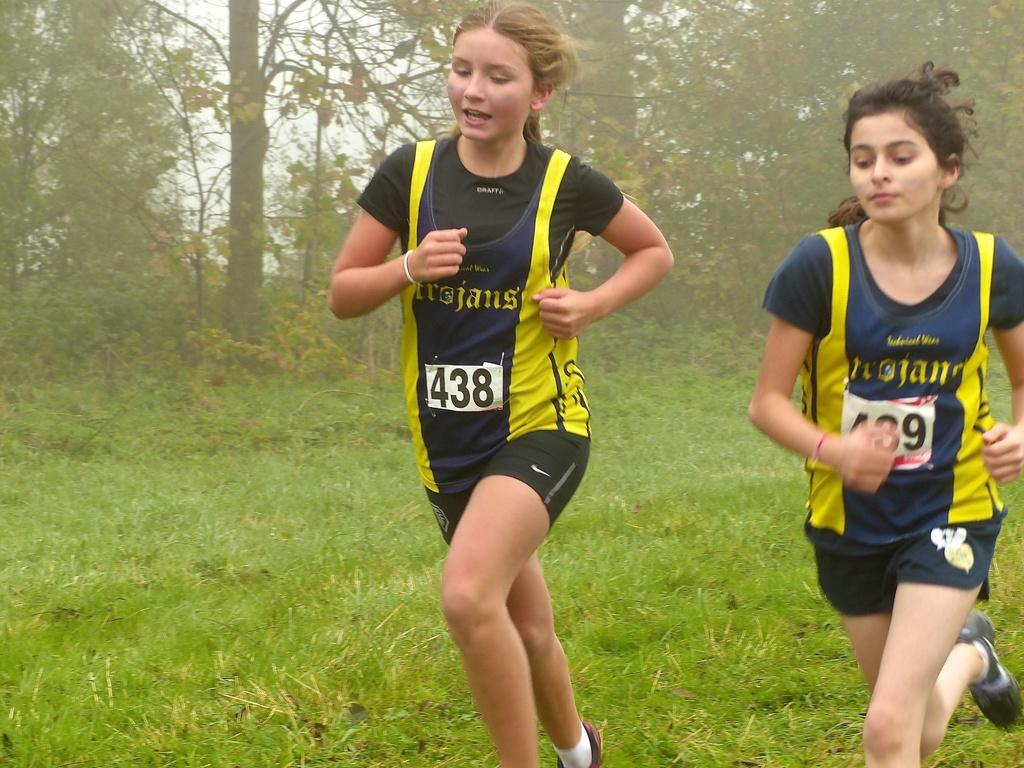How many people are in the foreground of the image? There are two women in the foreground of the image. What are the women doing in the image? The women are running on the grass. What can be seen in the background of the image? There are trees and the sky visible in the background of the image. What type of account is the band playing in the background of the image? There is no band present in the image, so it is not possible to determine what type of account they might be playing in. 